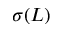Convert formula to latex. <formula><loc_0><loc_0><loc_500><loc_500>\sigma ( L )</formula> 